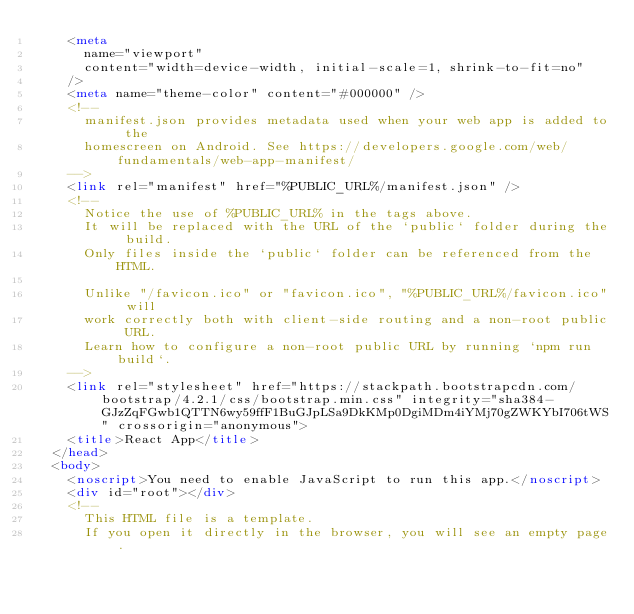Convert code to text. <code><loc_0><loc_0><loc_500><loc_500><_HTML_>    <meta
      name="viewport"
      content="width=device-width, initial-scale=1, shrink-to-fit=no"
    />
    <meta name="theme-color" content="#000000" />
    <!--
      manifest.json provides metadata used when your web app is added to the
      homescreen on Android. See https://developers.google.com/web/fundamentals/web-app-manifest/
    -->
    <link rel="manifest" href="%PUBLIC_URL%/manifest.json" />
    <!--
      Notice the use of %PUBLIC_URL% in the tags above.
      It will be replaced with the URL of the `public` folder during the build.
      Only files inside the `public` folder can be referenced from the HTML.

      Unlike "/favicon.ico" or "favicon.ico", "%PUBLIC_URL%/favicon.ico" will
      work correctly both with client-side routing and a non-root public URL.
      Learn how to configure a non-root public URL by running `npm run build`.
    -->
    <link rel="stylesheet" href="https://stackpath.bootstrapcdn.com/bootstrap/4.2.1/css/bootstrap.min.css" integrity="sha384-GJzZqFGwb1QTTN6wy59ffF1BuGJpLSa9DkKMp0DgiMDm4iYMj70gZWKYbI706tWS" crossorigin="anonymous">
    <title>React App</title>
  </head>
  <body>
    <noscript>You need to enable JavaScript to run this app.</noscript>
    <div id="root"></div>
    <!--
      This HTML file is a template.
      If you open it directly in the browser, you will see an empty page.
</code> 